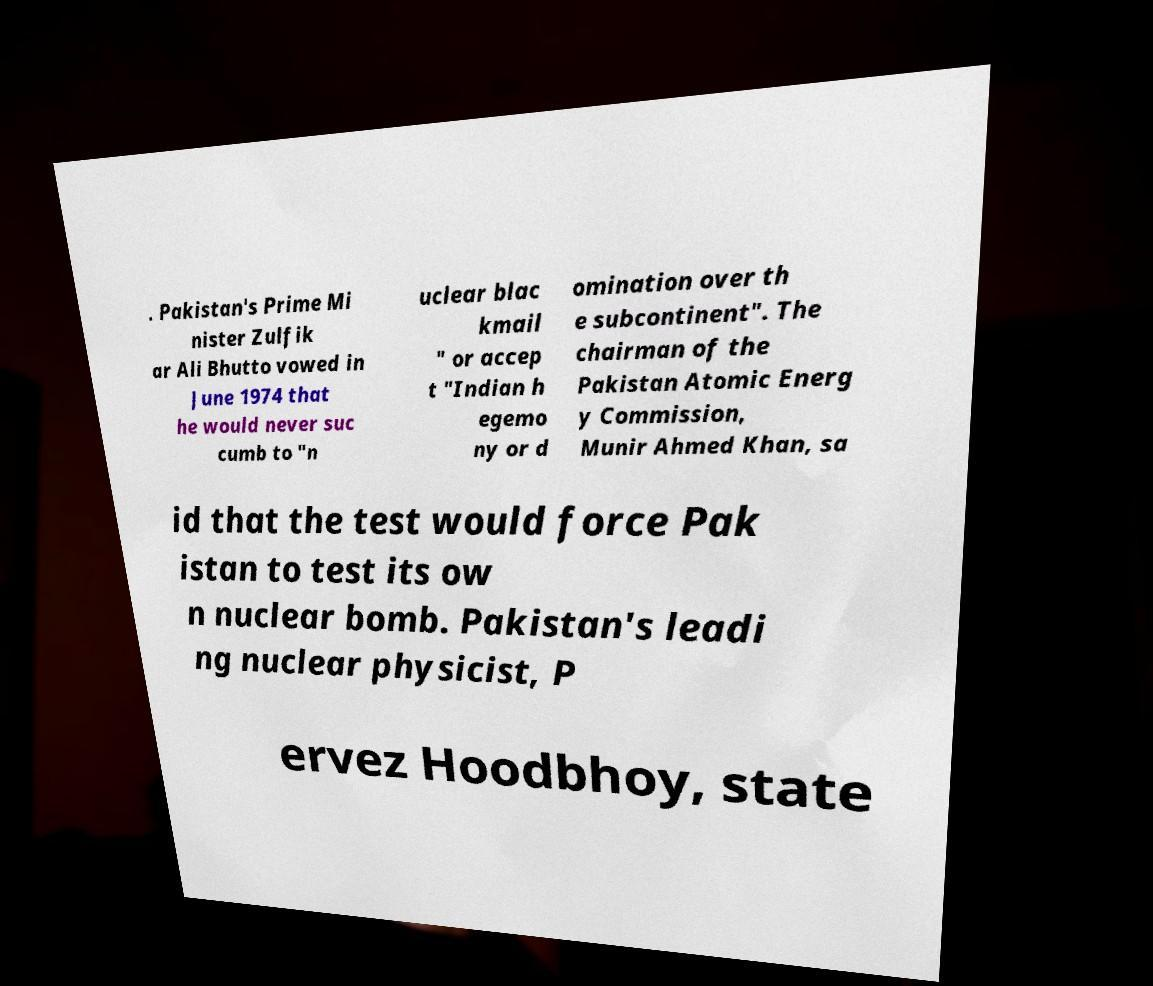Could you assist in decoding the text presented in this image and type it out clearly? . Pakistan's Prime Mi nister Zulfik ar Ali Bhutto vowed in June 1974 that he would never suc cumb to "n uclear blac kmail " or accep t "Indian h egemo ny or d omination over th e subcontinent". The chairman of the Pakistan Atomic Energ y Commission, Munir Ahmed Khan, sa id that the test would force Pak istan to test its ow n nuclear bomb. Pakistan's leadi ng nuclear physicist, P ervez Hoodbhoy, state 